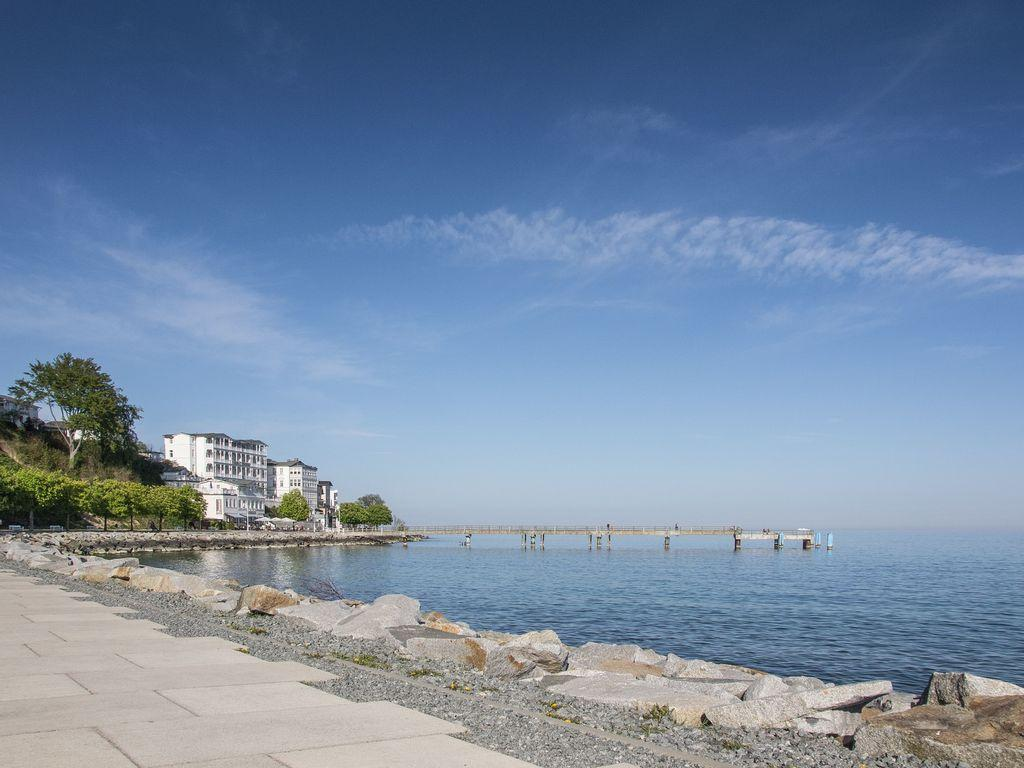What type of structure can be seen in the image? There is a walkway bridge in the image. What natural feature is visible in the image? The sea is visible in the image. What type of terrain is present in the image? Rocks are present in the image. What man-made structures can be seen in the image? There are buildings in the image. What type of vegetation is present in the image? Trees are present in the image. What type of landscape is visible in the image? Hills are visible in the image. What part of the natural environment is visible in the image? The sky is visible in the image. What atmospheric conditions can be observed in the sky? Clouds are present in the sky. Where is the clock located in the image? There is no clock present in the image. What type of sponge can be seen growing on the rocks in the image? There are no sponges present in the image, and rocks are not a habitat for sponges. What type of educational institution can be seen in the image? There is no school present in the image. 